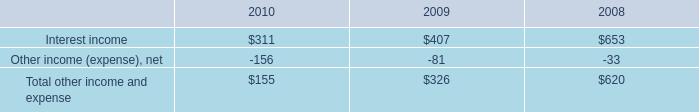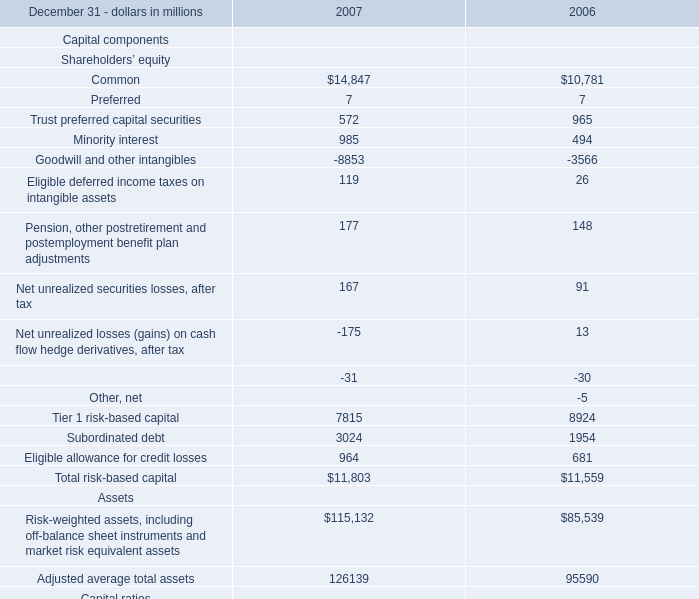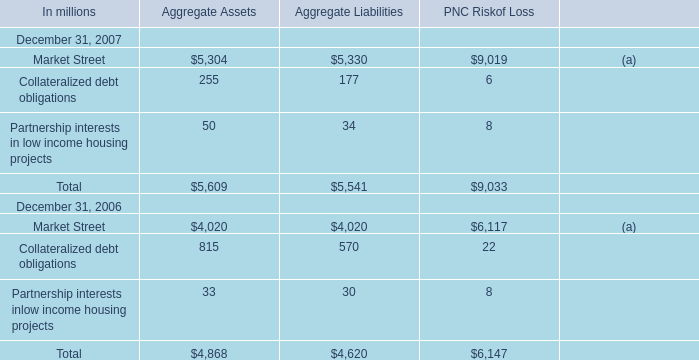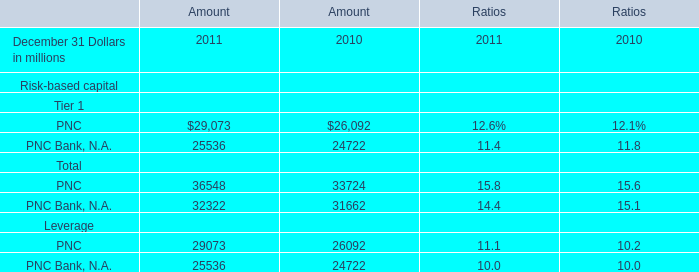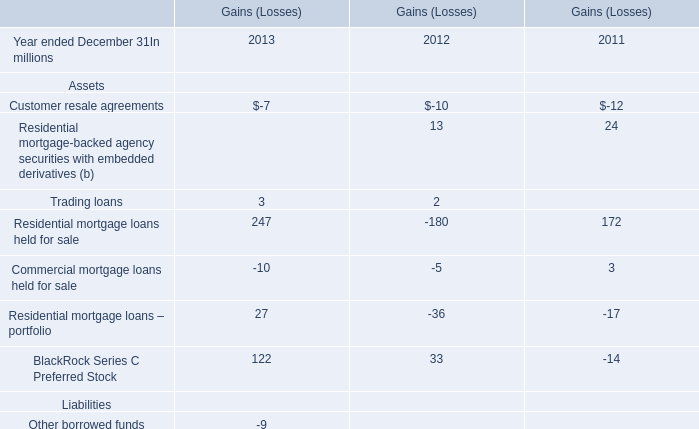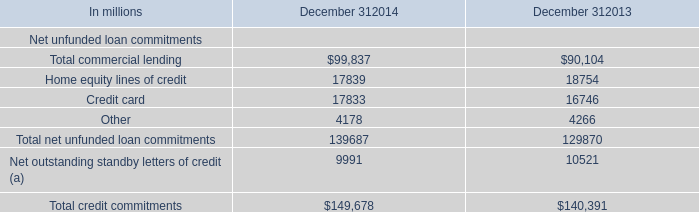by how much did total other income and expense decrease from 2009 to 2010? 
Computations: ((326 - 155) / 326)
Answer: 0.52454. 